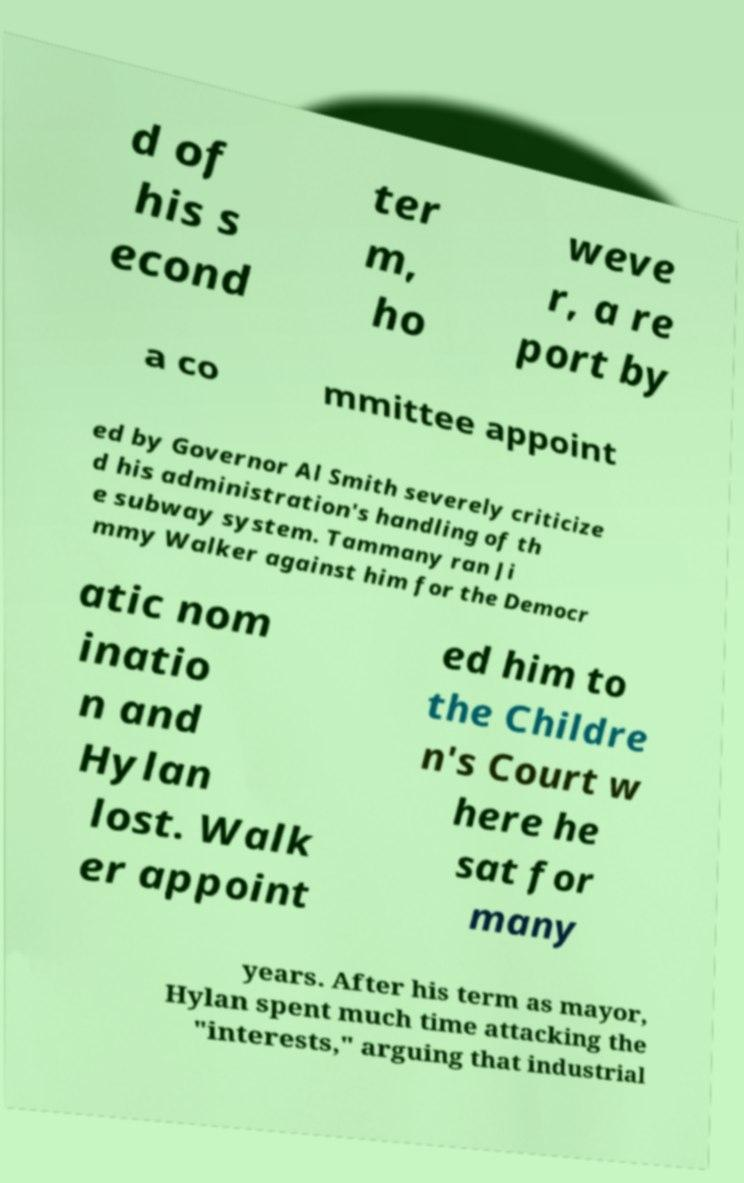Can you accurately transcribe the text from the provided image for me? d of his s econd ter m, ho weve r, a re port by a co mmittee appoint ed by Governor Al Smith severely criticize d his administration's handling of th e subway system. Tammany ran Ji mmy Walker against him for the Democr atic nom inatio n and Hylan lost. Walk er appoint ed him to the Childre n's Court w here he sat for many years. After his term as mayor, Hylan spent much time attacking the "interests," arguing that industrial 